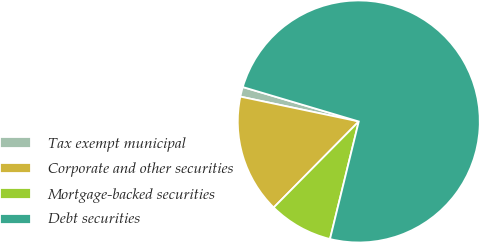Convert chart. <chart><loc_0><loc_0><loc_500><loc_500><pie_chart><fcel>Tax exempt municipal<fcel>Corporate and other securities<fcel>Mortgage-backed securities<fcel>Debt securities<nl><fcel>1.3%<fcel>15.88%<fcel>8.59%<fcel>74.22%<nl></chart> 